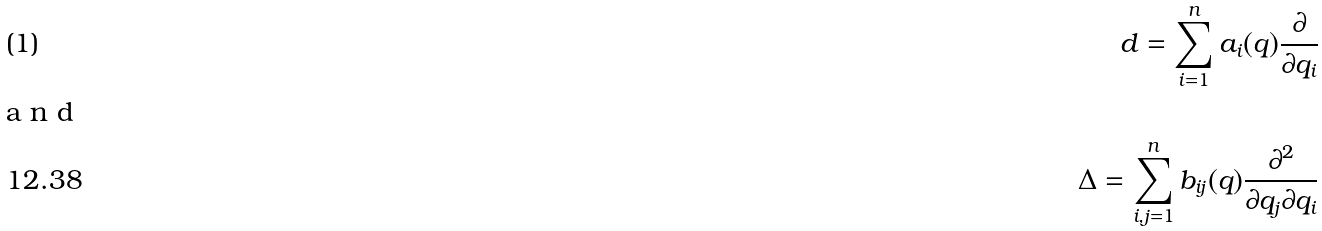Convert formula to latex. <formula><loc_0><loc_0><loc_500><loc_500>d = \sum _ { i = 1 } ^ { n } a _ { i } ( q ) \frac { \partial } { \partial q _ { i } } \intertext { a n d } \Delta = \sum _ { i , j = 1 } ^ { n } b _ { i j } ( q ) \frac { \partial ^ { 2 } } { \partial q _ { j } \partial q _ { i } }</formula> 